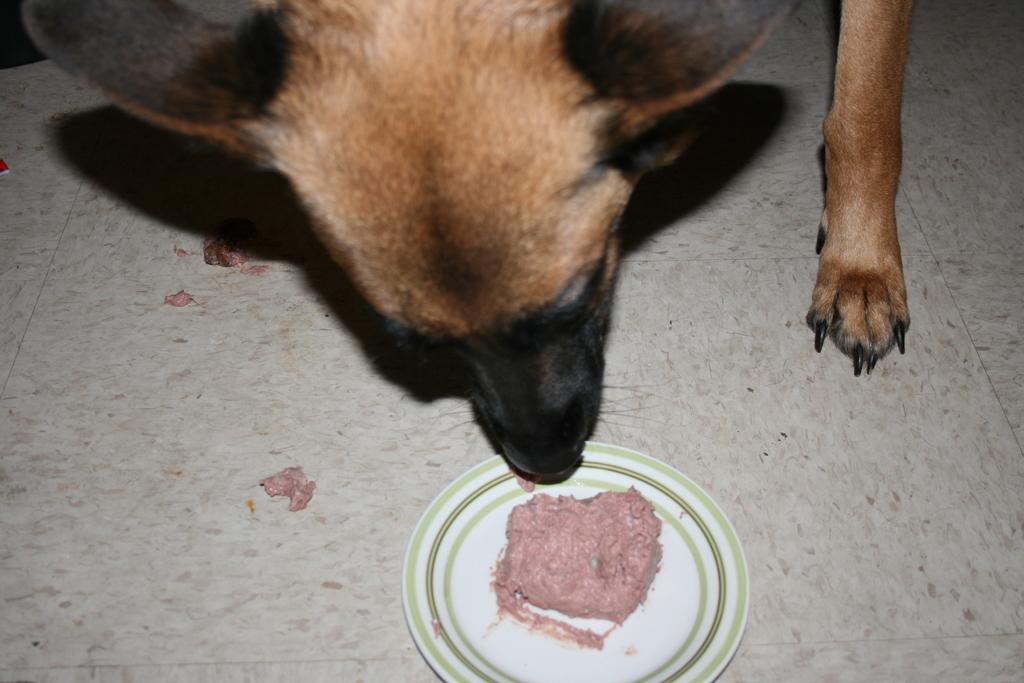How would you summarize this image in a sentence or two? At the top of the image, there is a dog keeping its mouth at the plate on which, there is a food item. This plate is on a floor. 